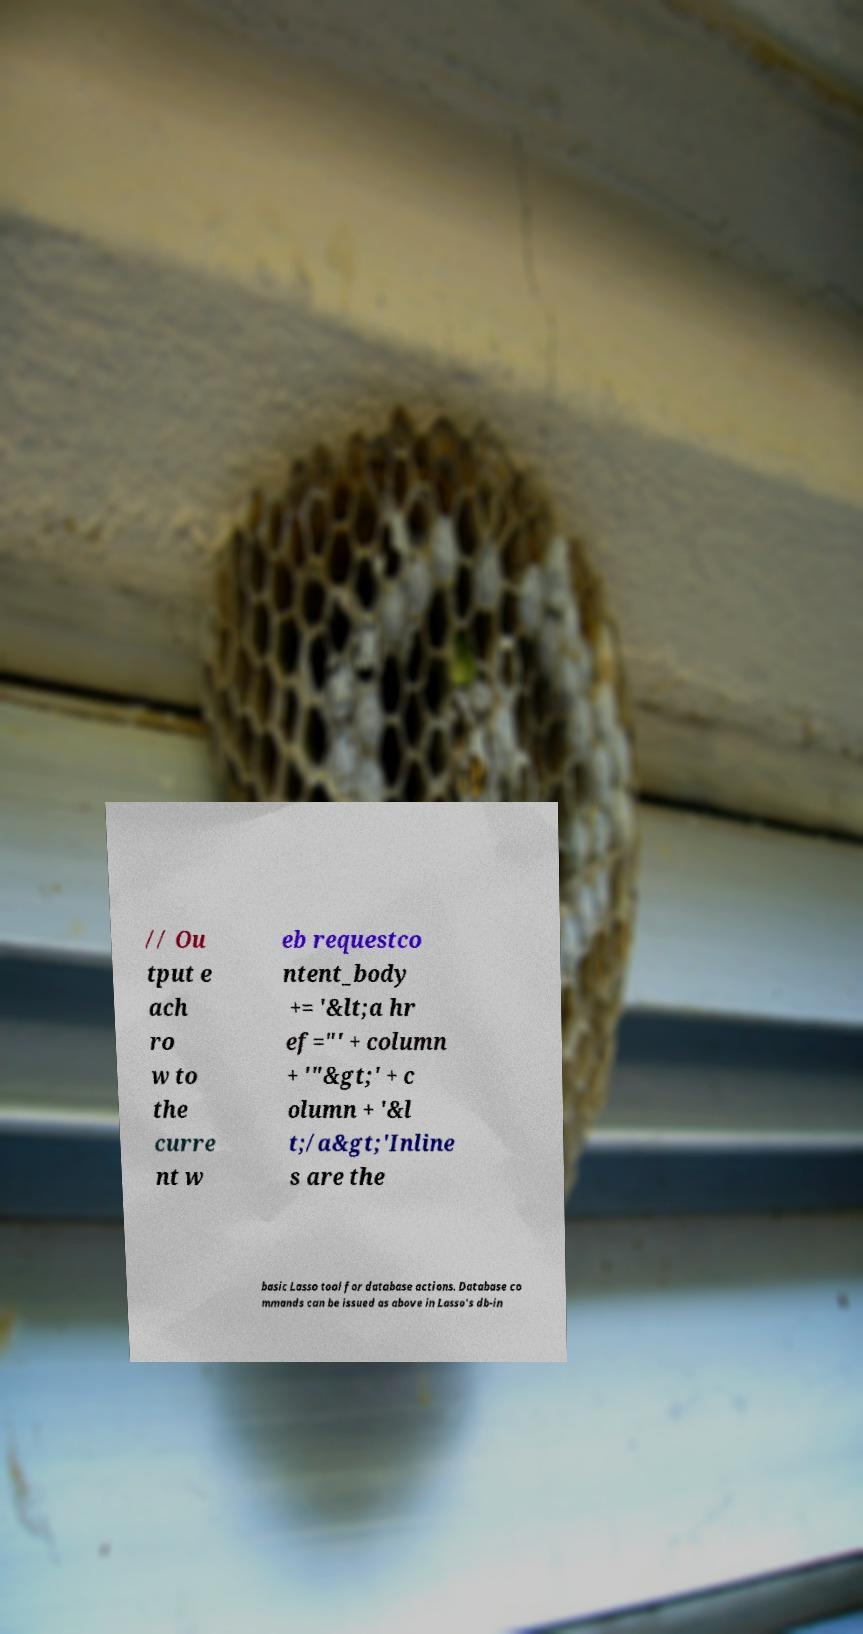Please identify and transcribe the text found in this image. // Ou tput e ach ro w to the curre nt w eb requestco ntent_body += '&lt;a hr ef="' + column + '"&gt;' + c olumn + '&l t;/a&gt;'Inline s are the basic Lasso tool for database actions. Database co mmands can be issued as above in Lasso's db-in 